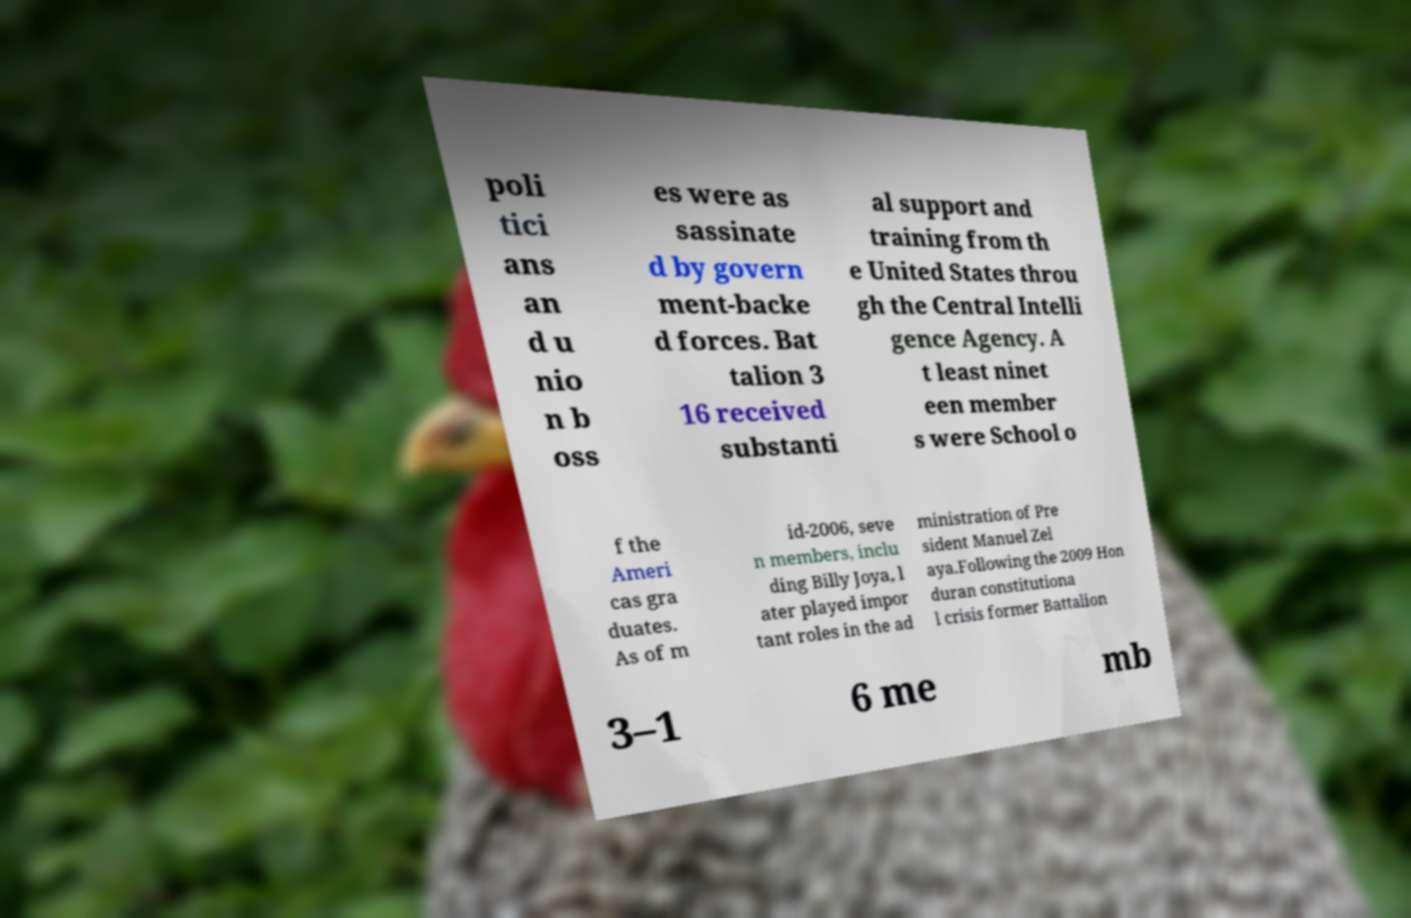Can you accurately transcribe the text from the provided image for me? poli tici ans an d u nio n b oss es were as sassinate d by govern ment-backe d forces. Bat talion 3 16 received substanti al support and training from th e United States throu gh the Central Intelli gence Agency. A t least ninet een member s were School o f the Ameri cas gra duates. As of m id-2006, seve n members, inclu ding Billy Joya, l ater played impor tant roles in the ad ministration of Pre sident Manuel Zel aya.Following the 2009 Hon duran constitutiona l crisis former Battalion 3–1 6 me mb 